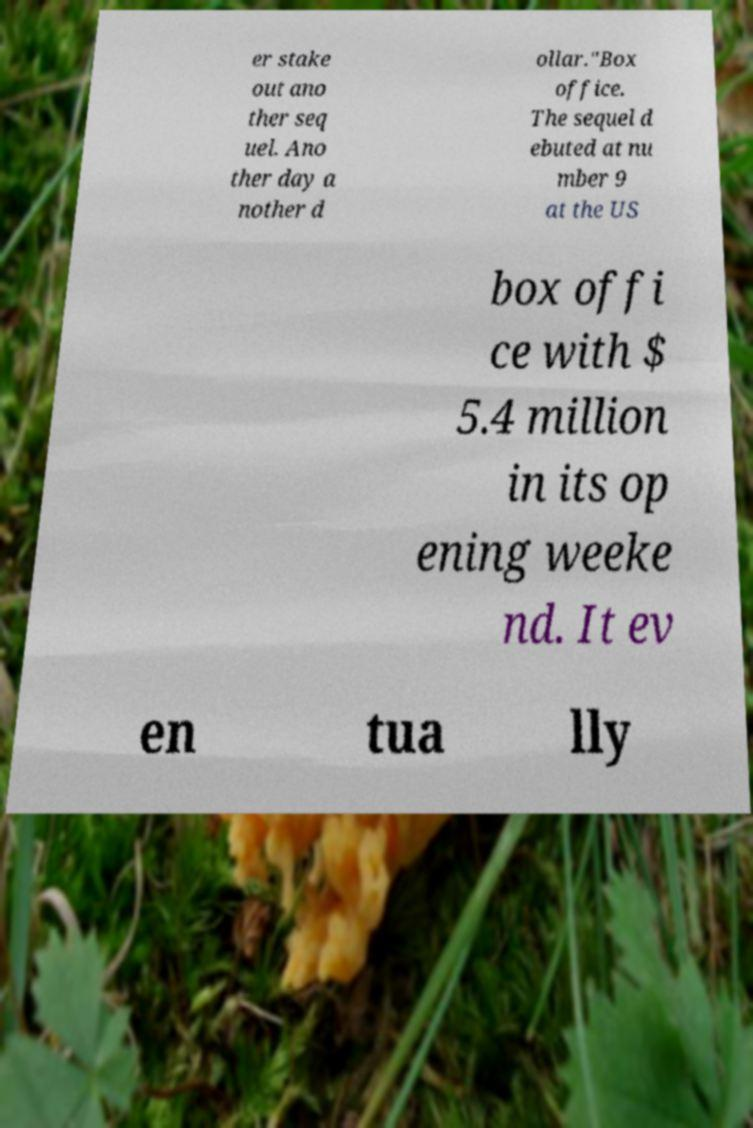Please identify and transcribe the text found in this image. er stake out ano ther seq uel. Ano ther day a nother d ollar."Box office. The sequel d ebuted at nu mber 9 at the US box offi ce with $ 5.4 million in its op ening weeke nd. It ev en tua lly 